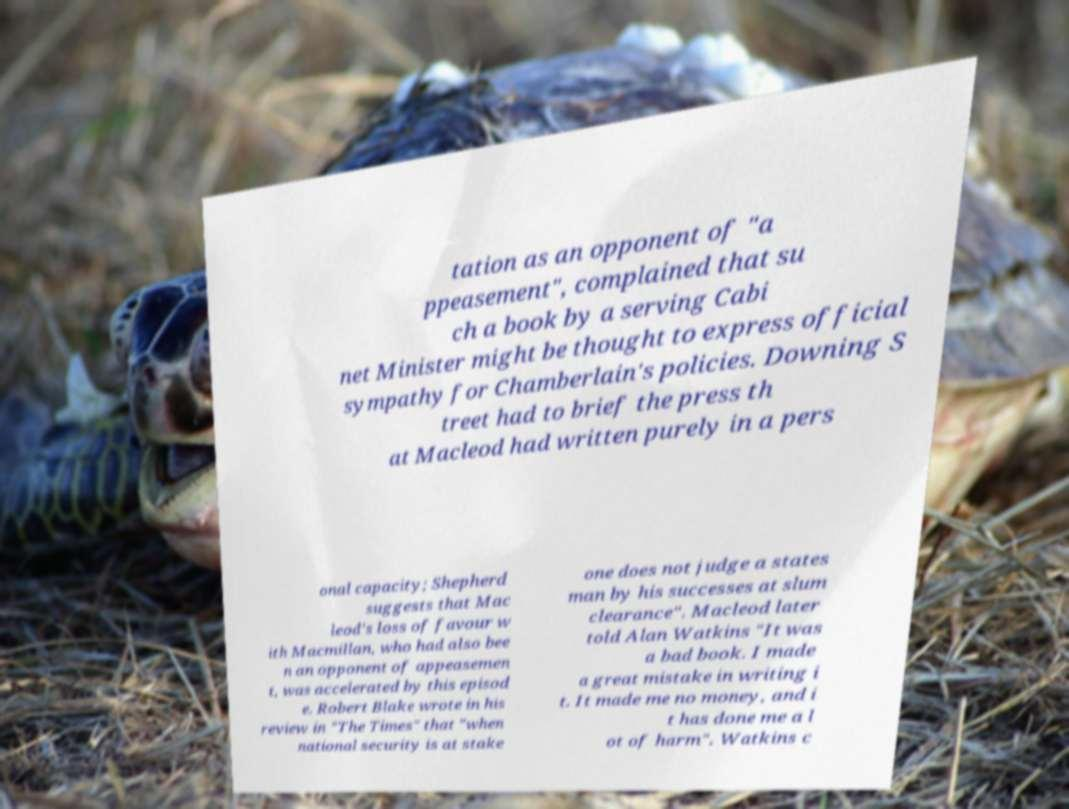Can you accurately transcribe the text from the provided image for me? tation as an opponent of "a ppeasement", complained that su ch a book by a serving Cabi net Minister might be thought to express official sympathy for Chamberlain's policies. Downing S treet had to brief the press th at Macleod had written purely in a pers onal capacity; Shepherd suggests that Mac leod's loss of favour w ith Macmillan, who had also bee n an opponent of appeasemen t, was accelerated by this episod e. Robert Blake wrote in his review in "The Times" that "when national security is at stake one does not judge a states man by his successes at slum clearance". Macleod later told Alan Watkins "It was a bad book. I made a great mistake in writing i t. It made me no money, and i t has done me a l ot of harm". Watkins c 